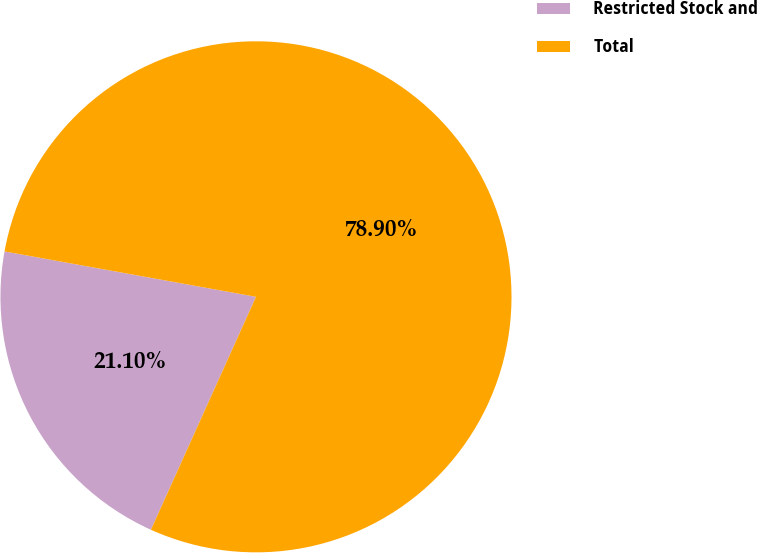Convert chart. <chart><loc_0><loc_0><loc_500><loc_500><pie_chart><fcel>Restricted Stock and<fcel>Total<nl><fcel>21.1%<fcel>78.9%<nl></chart> 